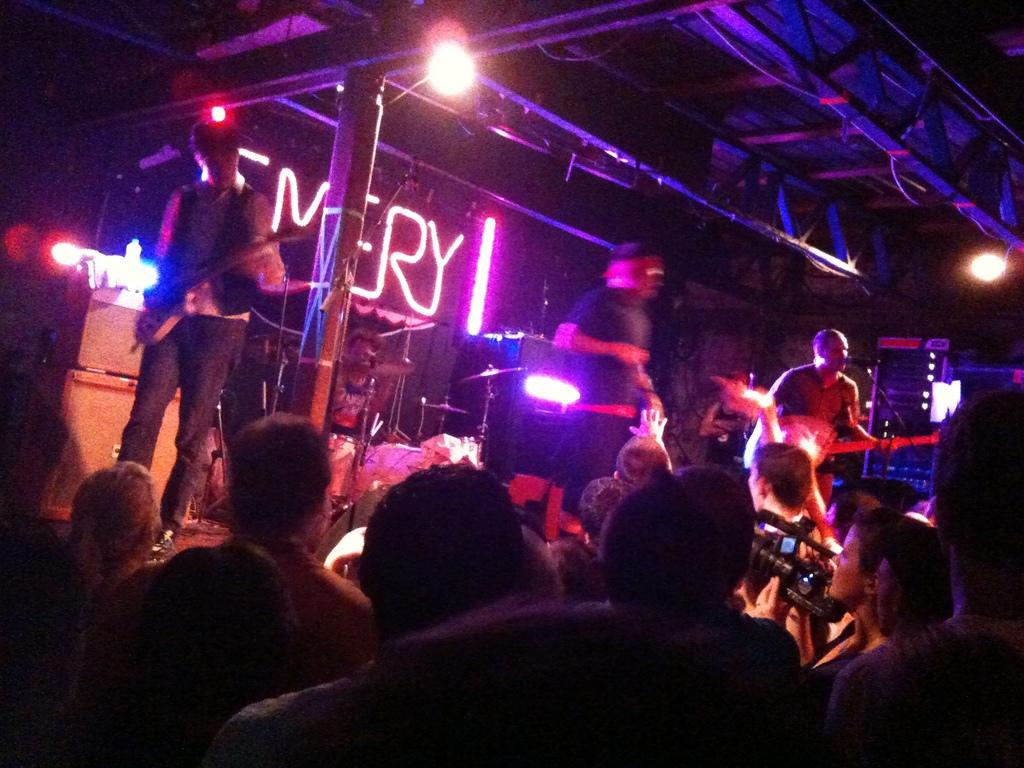How many people are in the group visible in the image? There is a group of people standing in the image, but the exact number is not specified. What is the person holding in the image? The person is holding a camera in the image. How many guitars are being held by the group in the image? There are three persons holding guitars in the image. What type of equipment is present in the image for lighting purposes? There is a lighting truss and focus lights in the image for lighting purposes. What musical instrument is visible on stands in the image? Cymbals are on cymbal stands in the image. What object can be seen that is not related to music or lighting? There is a bottle in the image. What type of health advice is being given in the image? There is no indication of health advice being given in the image; it features a group of people, a person holding a camera, and musical equipment. What type of stove is visible in the image? There is no stove present in the image. What type of corn is visible in the image? There is no corn present in the image. 